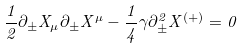<formula> <loc_0><loc_0><loc_500><loc_500>\frac { 1 } { 2 } \partial _ { \pm } X _ { \mu } \partial _ { \pm } X ^ { \mu } - \frac { 1 } { 4 } \gamma \partial ^ { 2 } _ { \pm } X ^ { ( + ) } = 0</formula> 